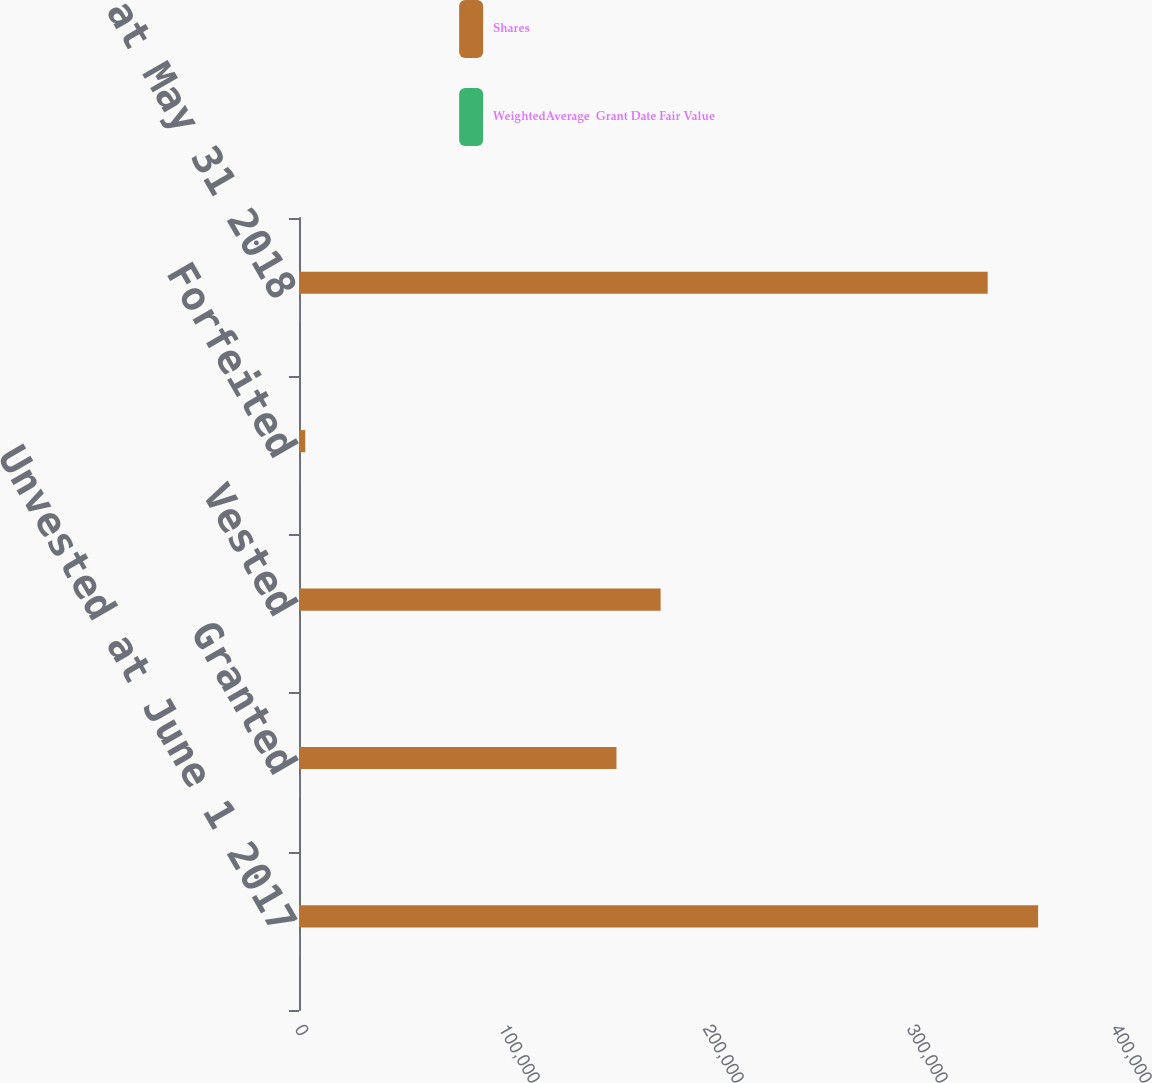Convert chart. <chart><loc_0><loc_0><loc_500><loc_500><stacked_bar_chart><ecel><fcel>Unvested at June 1 2017<fcel>Granted<fcel>Vested<fcel>Forfeited<fcel>Unvested at May 31 2018<nl><fcel>Shares<fcel>362304<fcel>155624<fcel>177264<fcel>3074<fcel>337590<nl><fcel>WeightedAverage  Grant Date Fair Value<fcel>155.53<fcel>212.6<fcel>148.94<fcel>148.95<fcel>185.16<nl></chart> 